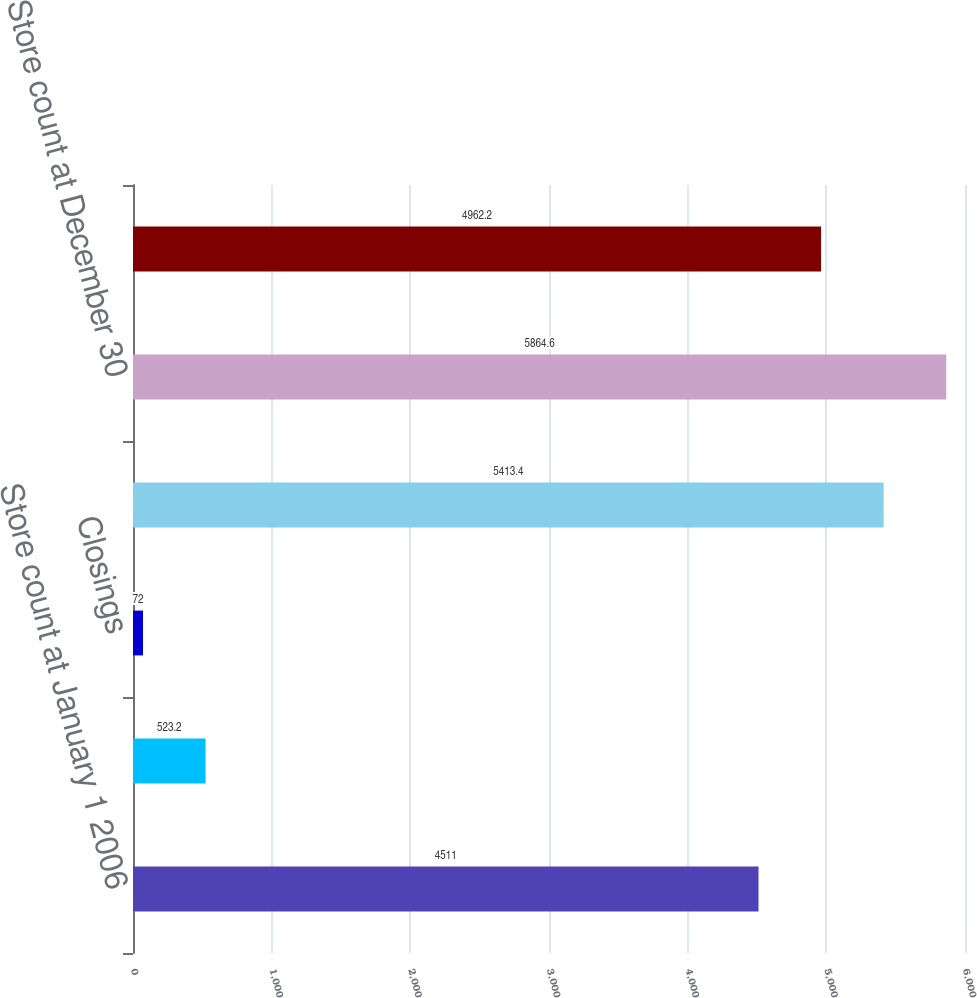Convert chart to OTSL. <chart><loc_0><loc_0><loc_500><loc_500><bar_chart><fcel>Store count at January 1 2006<fcel>Openings<fcel>Closings<fcel>Store count at December 31<fcel>Store count at December 30<fcel>Store count at December 28<nl><fcel>4511<fcel>523.2<fcel>72<fcel>5413.4<fcel>5864.6<fcel>4962.2<nl></chart> 